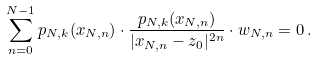Convert formula to latex. <formula><loc_0><loc_0><loc_500><loc_500>\sum _ { n = 0 } ^ { N - 1 } p _ { N , k } ( x _ { N , n } ) \cdot \frac { p _ { N , k } ( x _ { N , n } ) } { | x _ { N , n } - z _ { 0 } | ^ { 2 n } } \cdot w _ { N , n } = 0 \, .</formula> 